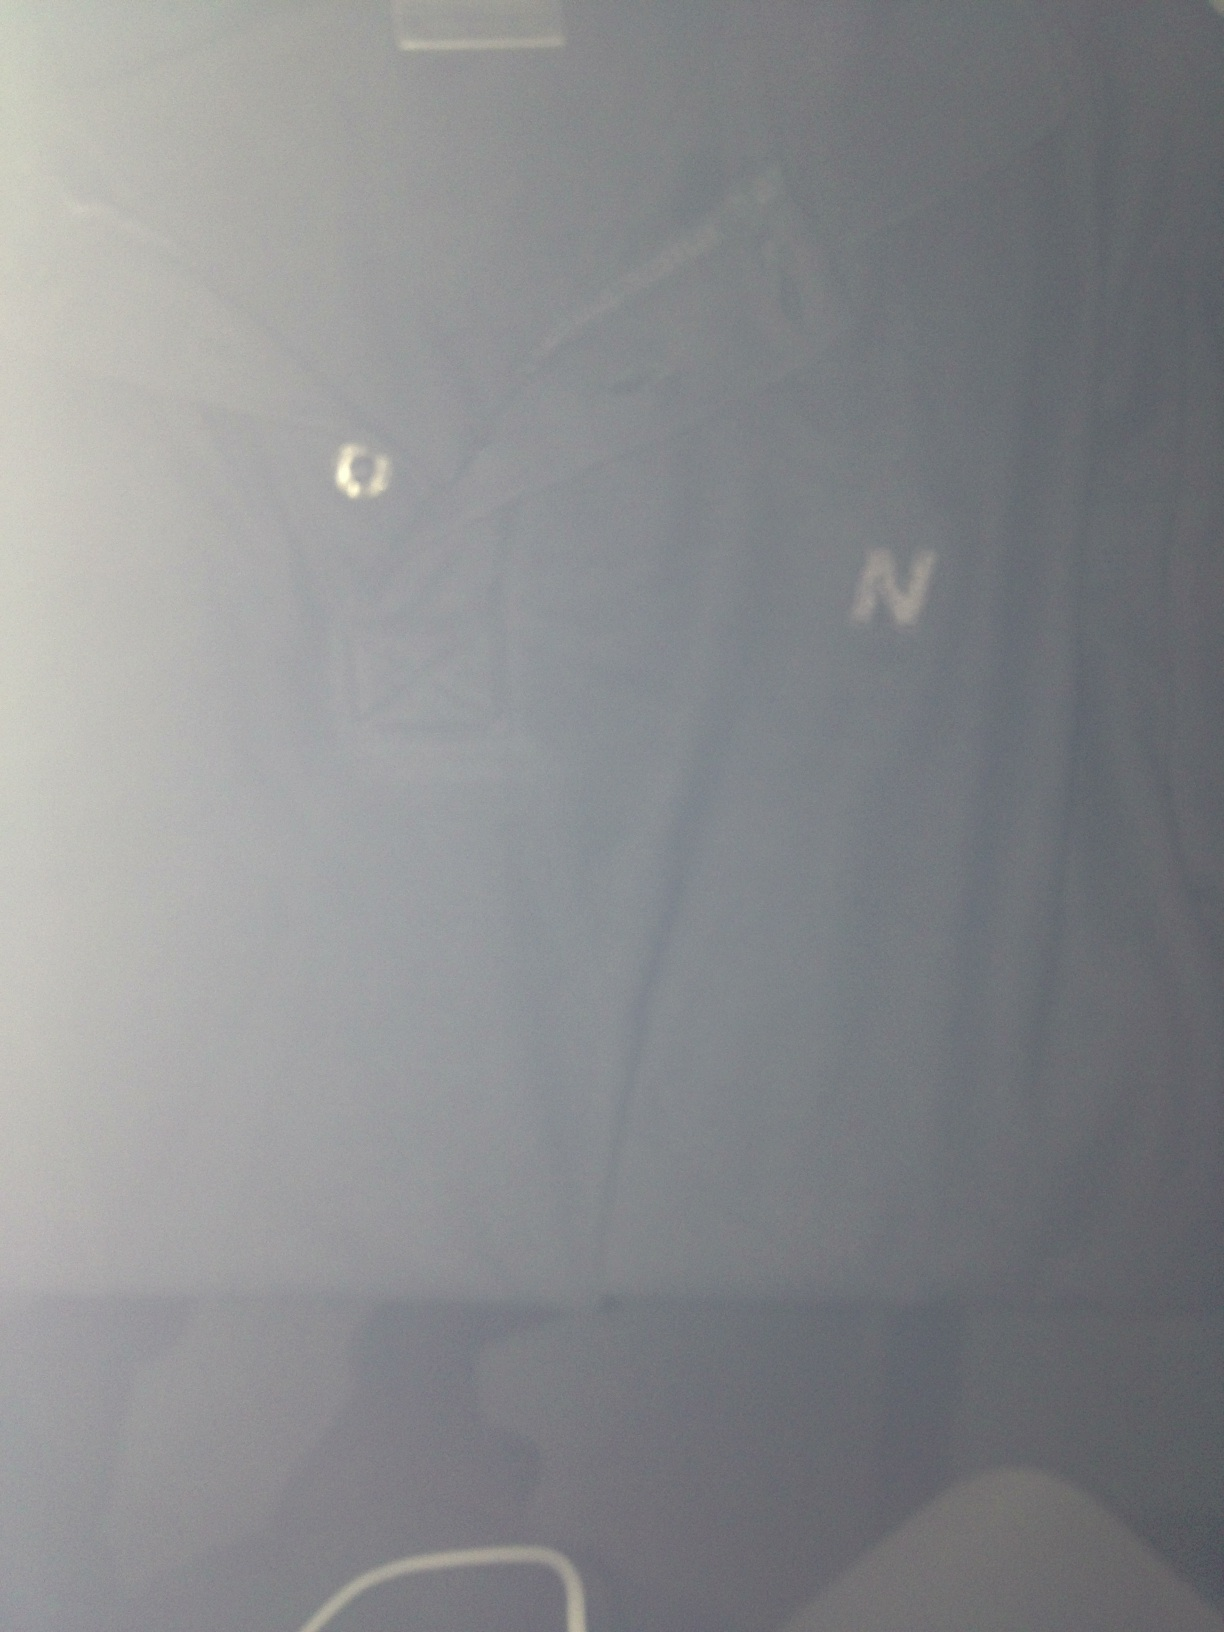what color is this tee shirt? thank you The color of this tee shirt appears to be a shade of dark blue or navy. Thank you for your question! 